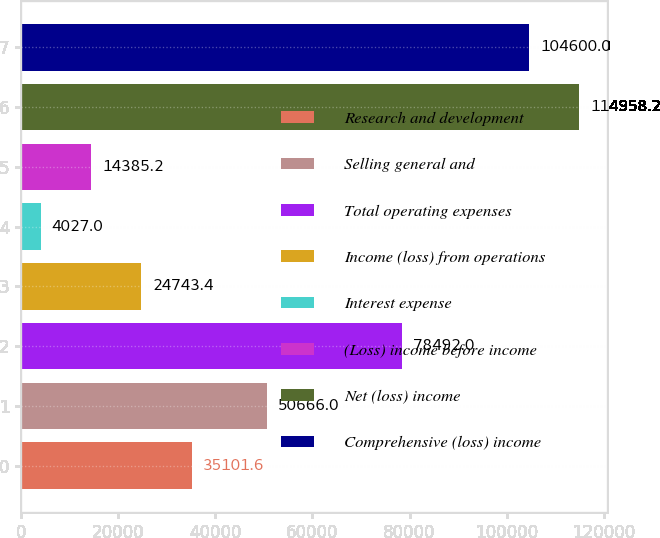<chart> <loc_0><loc_0><loc_500><loc_500><bar_chart><fcel>Research and development<fcel>Selling general and<fcel>Total operating expenses<fcel>Income (loss) from operations<fcel>Interest expense<fcel>(Loss) income before income<fcel>Net (loss) income<fcel>Comprehensive (loss) income<nl><fcel>35101.6<fcel>50666<fcel>78492<fcel>24743.4<fcel>4027<fcel>14385.2<fcel>114958<fcel>104600<nl></chart> 